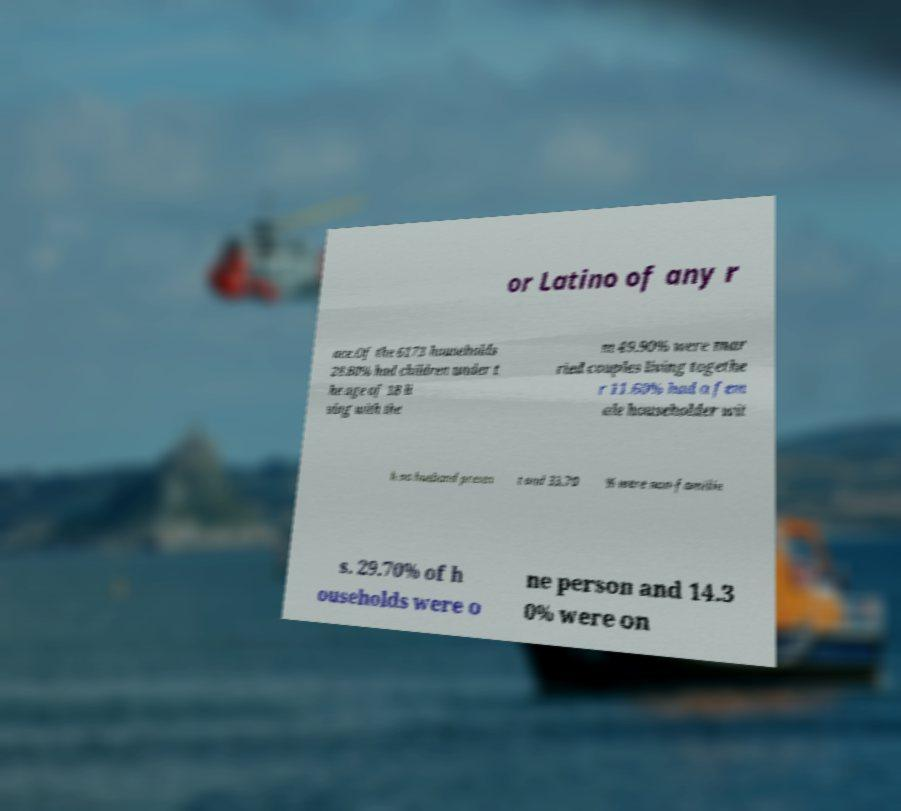For documentation purposes, I need the text within this image transcribed. Could you provide that? or Latino of any r ace.Of the 6173 households 28.80% had children under t he age of 18 li ving with the m 49.90% were mar ried couples living togethe r 11.60% had a fem ale householder wit h no husband presen t and 33.70 % were non-familie s. 29.70% of h ouseholds were o ne person and 14.3 0% were on 